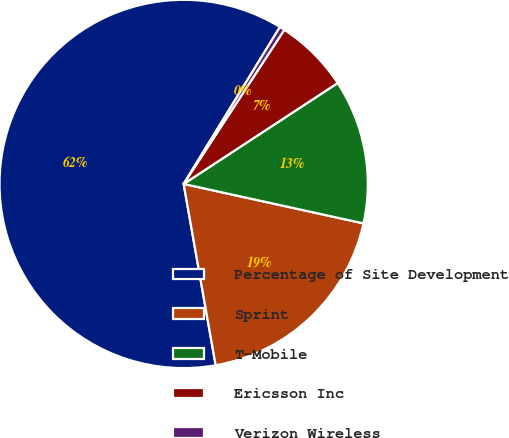Convert chart. <chart><loc_0><loc_0><loc_500><loc_500><pie_chart><fcel>Percentage of Site Development<fcel>Sprint<fcel>T-Mobile<fcel>Ericsson Inc<fcel>Verizon Wireless<nl><fcel>61.54%<fcel>18.78%<fcel>12.67%<fcel>6.56%<fcel>0.45%<nl></chart> 